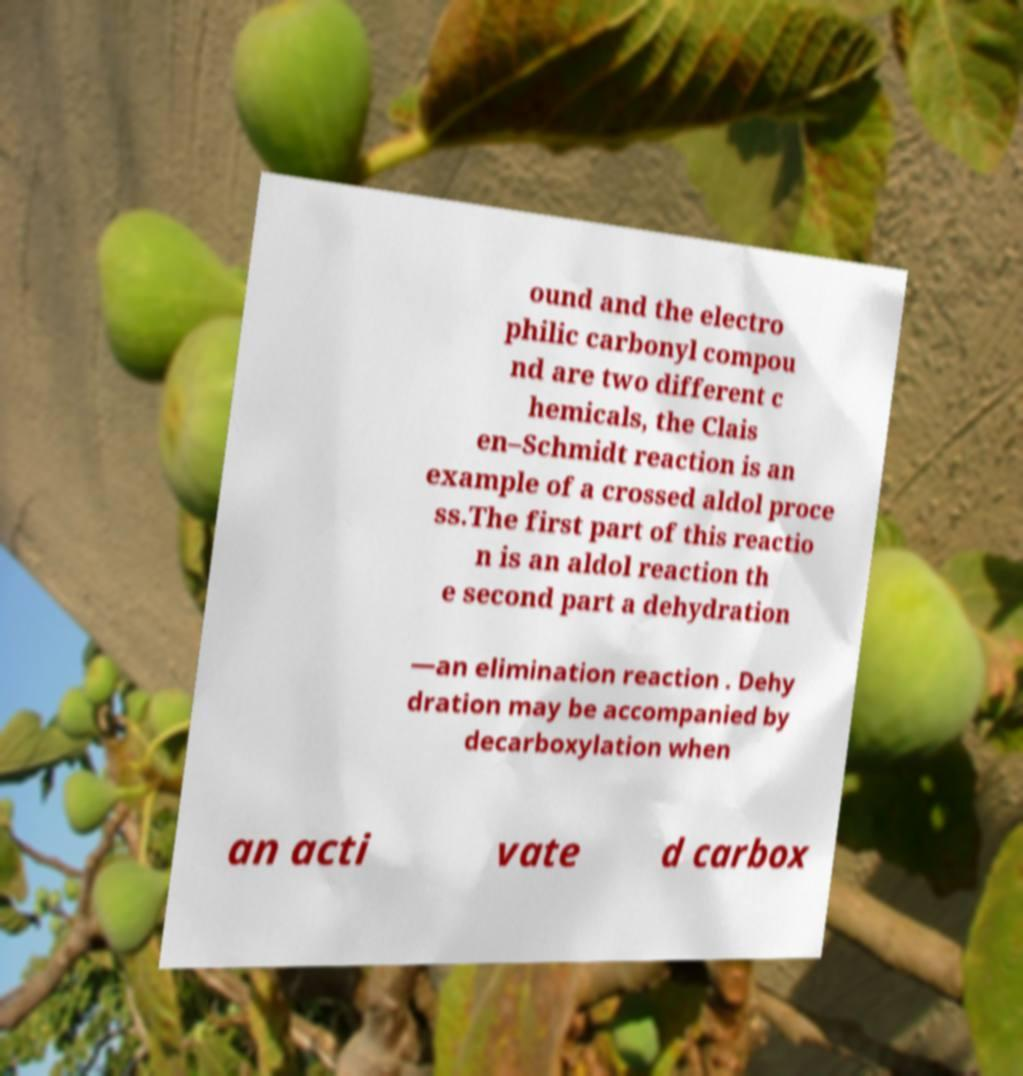What messages or text are displayed in this image? I need them in a readable, typed format. ound and the electro philic carbonyl compou nd are two different c hemicals, the Clais en–Schmidt reaction is an example of a crossed aldol proce ss.The first part of this reactio n is an aldol reaction th e second part a dehydration —an elimination reaction . Dehy dration may be accompanied by decarboxylation when an acti vate d carbox 